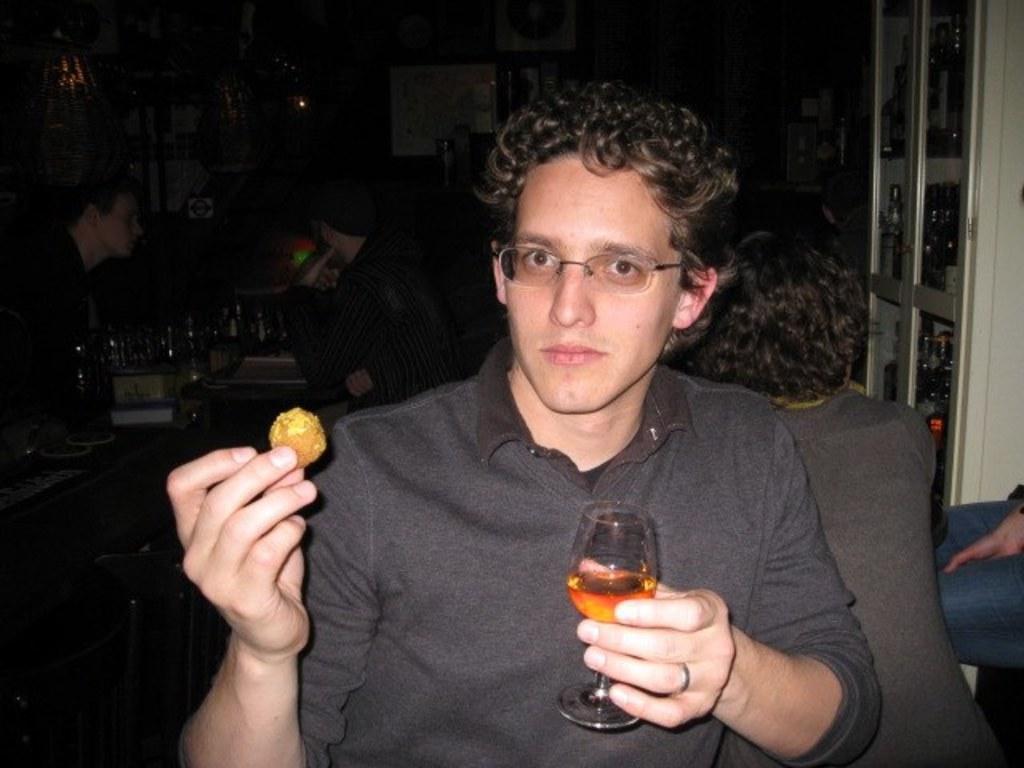In one or two sentences, can you explain what this image depicts? There is a man holding meat ball and glass of wine in hand. 